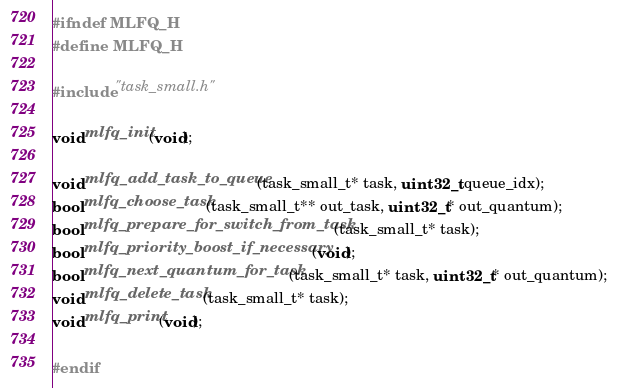Convert code to text. <code><loc_0><loc_0><loc_500><loc_500><_C_>#ifndef MLFQ_H
#define MLFQ_H

#include "task_small.h"

void mlfq_init(void);

void mlfq_add_task_to_queue(task_small_t* task, uint32_t queue_idx);
bool mlfq_choose_task(task_small_t** out_task, uint32_t* out_quantum);
bool mlfq_prepare_for_switch_from_task(task_small_t* task);
bool mlfq_priority_boost_if_necessary(void);
bool mlfq_next_quantum_for_task(task_small_t* task, uint32_t* out_quantum);
void mlfq_delete_task(task_small_t* task);
void mlfq_print(void);

#endif</code> 